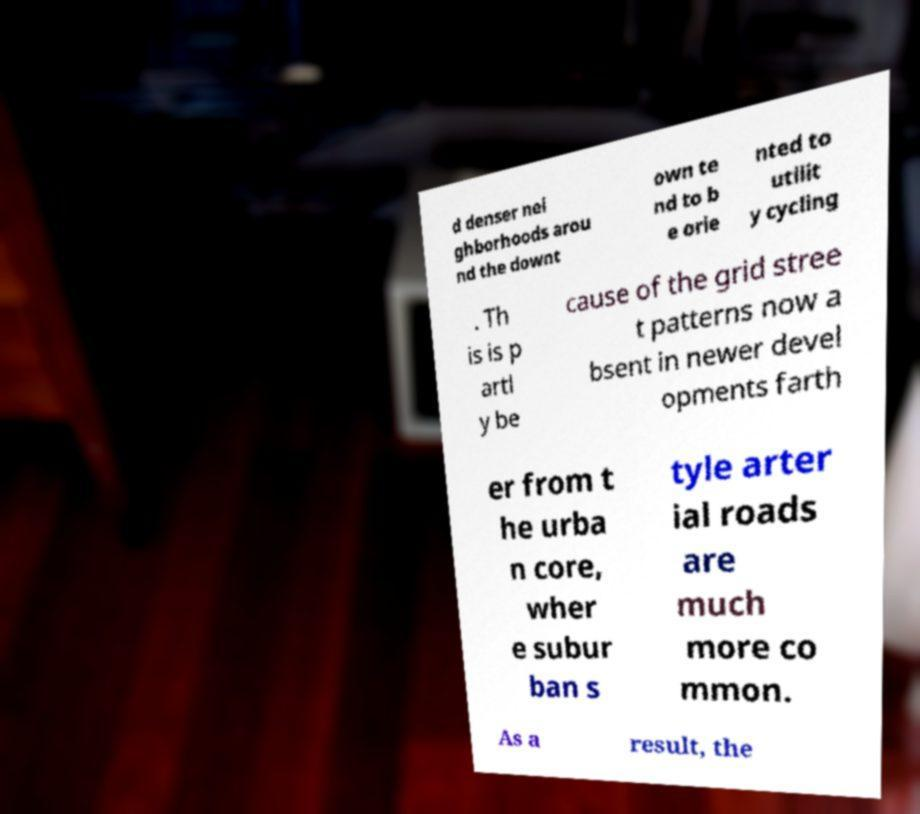Could you extract and type out the text from this image? d denser nei ghborhoods arou nd the downt own te nd to b e orie nted to utilit y cycling . Th is is p artl y be cause of the grid stree t patterns now a bsent in newer devel opments farth er from t he urba n core, wher e subur ban s tyle arter ial roads are much more co mmon. As a result, the 